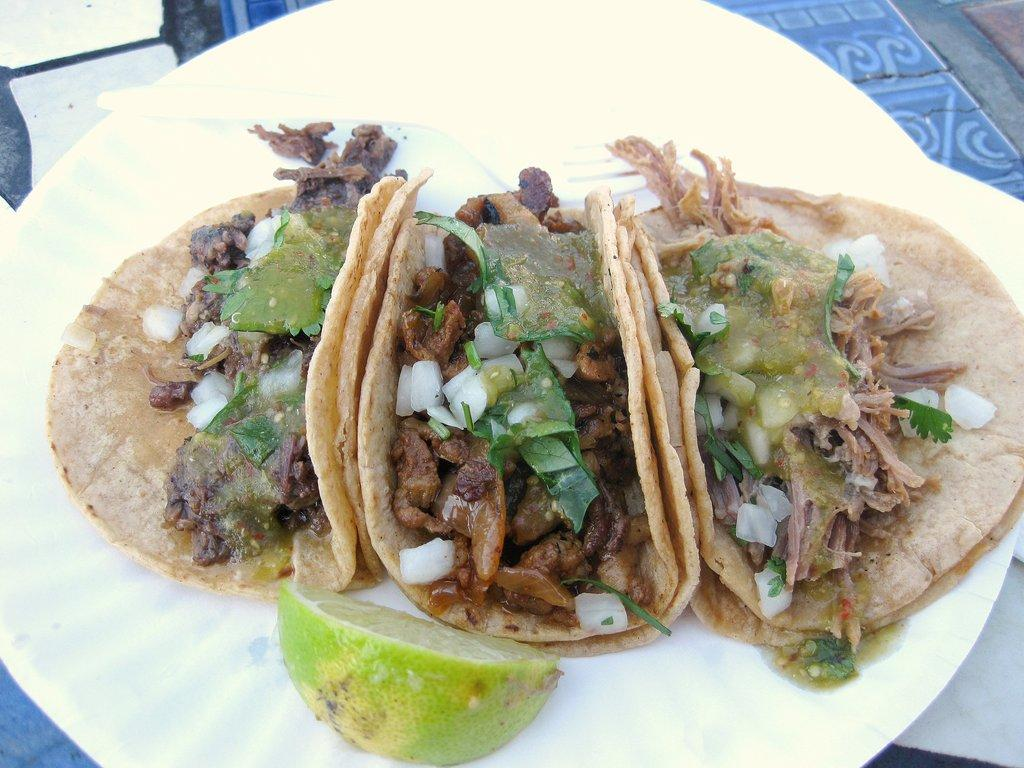What is the color of the plate in the image? The plate in the image is white. What is on the plate? There are different types of food on the plate, including a lemon. Can you describe the food on the plate? Unfortunately, the specific types of food cannot be determined from the provided facts. What type of desk is visible in the image? There is no desk present in the image; it only features a white plate with different types of food and a lemon. 